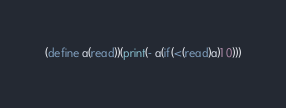Convert code to text. <code><loc_0><loc_0><loc_500><loc_500><_Scheme_>(define a(read))(print(- a(if(<(read)a)1 0)))</code> 